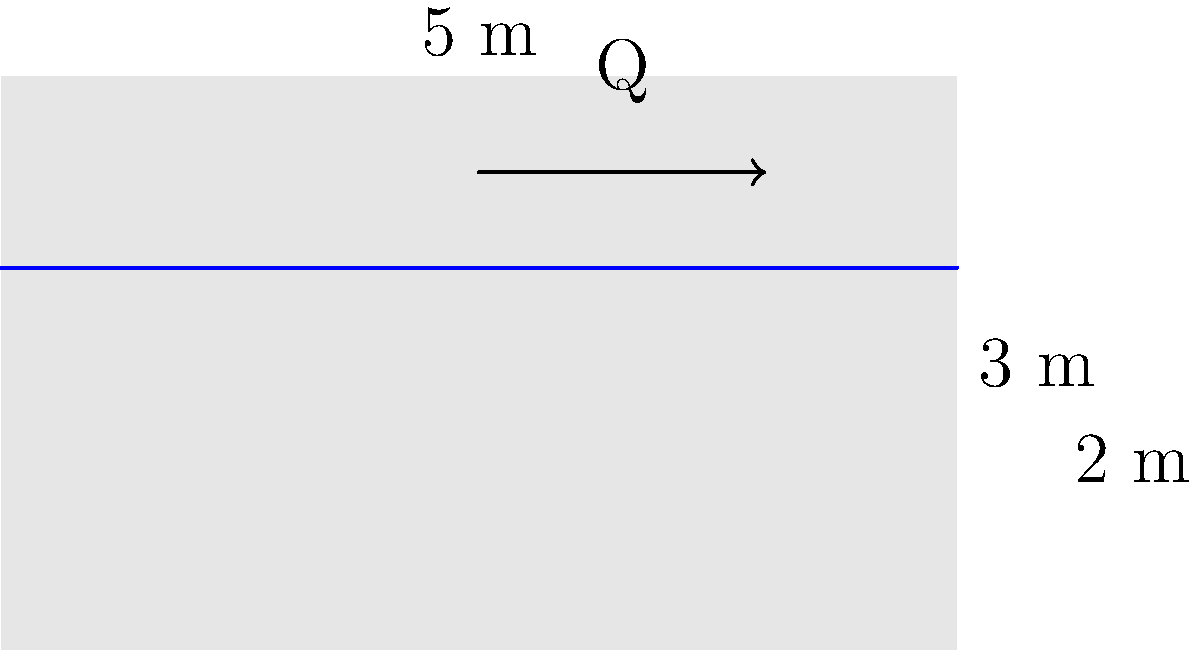In an open rectangular channel with a width of 5 m and a depth of 3 m, water is flowing at a depth of 2 m. If the average velocity of the water is 1.5 m/s, what is the flow rate (Q) in the channel? To solve this problem, we'll use the continuity equation for fluid flow:

$$ Q = A \times v $$

Where:
- $Q$ is the flow rate (m³/s)
- $A$ is the cross-sectional area of flow (m²)
- $v$ is the average velocity (m/s)

Steps to solve:

1. Calculate the cross-sectional area of flow:
   $A = \text{width} \times \text{water depth}$
   $A = 5 \text{ m} \times 2 \text{ m} = 10 \text{ m}^2$

2. Use the given average velocity:
   $v = 1.5 \text{ m/s}$

3. Apply the continuity equation:
   $Q = A \times v$
   $Q = 10 \text{ m}^2 \times 1.5 \text{ m/s}$
   $Q = 15 \text{ m}^3/\text{s}$

Therefore, the flow rate in the channel is 15 m³/s.
Answer: 15 m³/s 